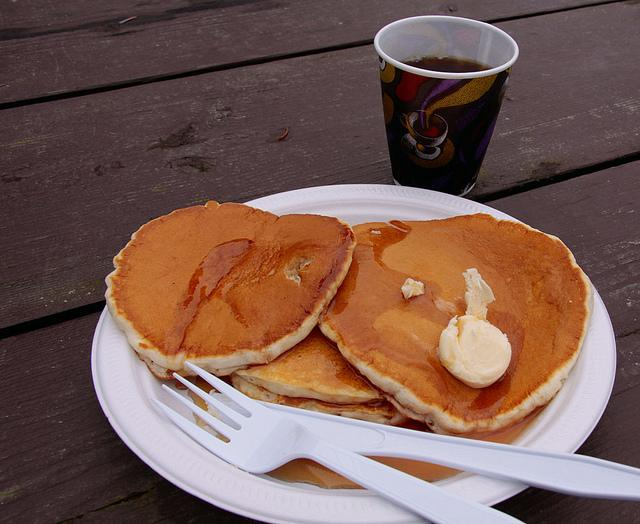On what surface is this plate of pancakes placed upon? Please explain your reasoning. park bench. It is placed on a picnic table, which is a table where food is eaten. 